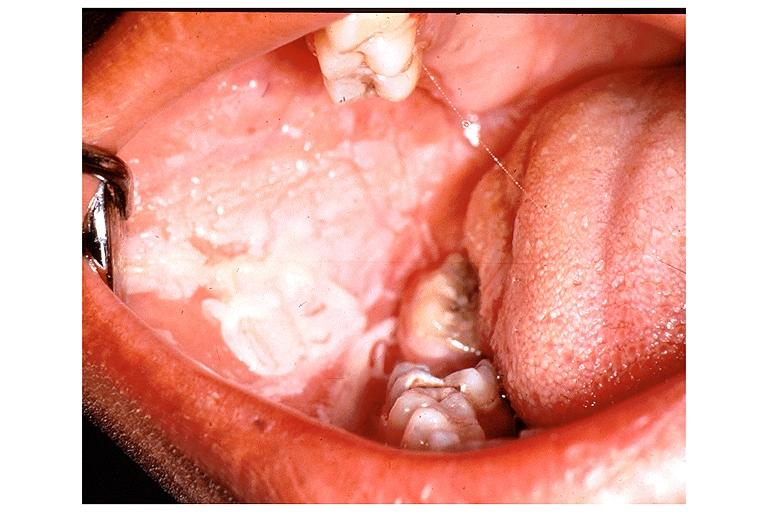does this image show chemical burn from topical asprin?
Answer the question using a single word or phrase. Yes 